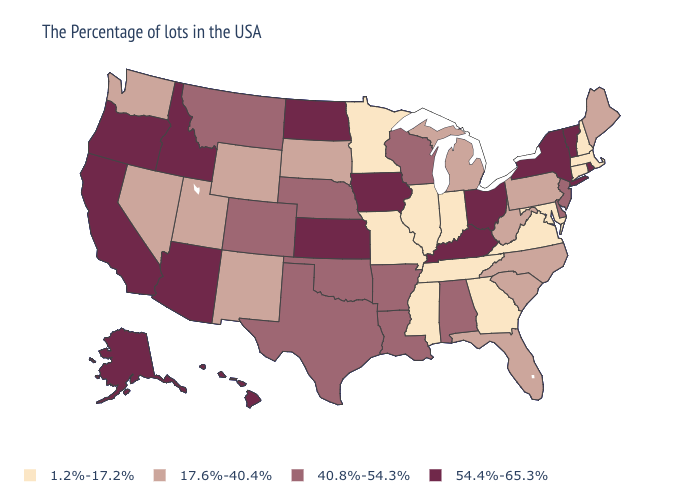Is the legend a continuous bar?
Short answer required. No. Which states hav the highest value in the South?
Be succinct. Kentucky. Does Massachusetts have the lowest value in the USA?
Short answer required. Yes. Which states have the lowest value in the USA?
Concise answer only. Massachusetts, New Hampshire, Connecticut, Maryland, Virginia, Georgia, Indiana, Tennessee, Illinois, Mississippi, Missouri, Minnesota. Name the states that have a value in the range 54.4%-65.3%?
Quick response, please. Rhode Island, Vermont, New York, Ohio, Kentucky, Iowa, Kansas, North Dakota, Arizona, Idaho, California, Oregon, Alaska, Hawaii. How many symbols are there in the legend?
Short answer required. 4. Which states have the highest value in the USA?
Quick response, please. Rhode Island, Vermont, New York, Ohio, Kentucky, Iowa, Kansas, North Dakota, Arizona, Idaho, California, Oregon, Alaska, Hawaii. Name the states that have a value in the range 17.6%-40.4%?
Answer briefly. Maine, Pennsylvania, North Carolina, South Carolina, West Virginia, Florida, Michigan, South Dakota, Wyoming, New Mexico, Utah, Nevada, Washington. Does the first symbol in the legend represent the smallest category?
Quick response, please. Yes. Name the states that have a value in the range 17.6%-40.4%?
Be succinct. Maine, Pennsylvania, North Carolina, South Carolina, West Virginia, Florida, Michigan, South Dakota, Wyoming, New Mexico, Utah, Nevada, Washington. What is the value of Ohio?
Concise answer only. 54.4%-65.3%. What is the lowest value in states that border California?
Write a very short answer. 17.6%-40.4%. Name the states that have a value in the range 54.4%-65.3%?
Write a very short answer. Rhode Island, Vermont, New York, Ohio, Kentucky, Iowa, Kansas, North Dakota, Arizona, Idaho, California, Oregon, Alaska, Hawaii. What is the value of Missouri?
Concise answer only. 1.2%-17.2%. What is the value of Iowa?
Write a very short answer. 54.4%-65.3%. 